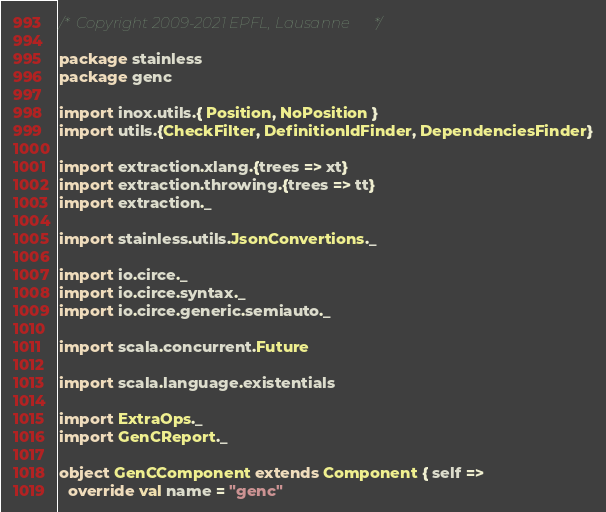Convert code to text. <code><loc_0><loc_0><loc_500><loc_500><_Scala_>/* Copyright 2009-2021 EPFL, Lausanne */

package stainless
package genc

import inox.utils.{ Position, NoPosition }
import utils.{CheckFilter, DefinitionIdFinder, DependenciesFinder}

import extraction.xlang.{trees => xt}
import extraction.throwing.{trees => tt}
import extraction._

import stainless.utils.JsonConvertions._

import io.circe._
import io.circe.syntax._
import io.circe.generic.semiauto._

import scala.concurrent.Future

import scala.language.existentials

import ExtraOps._
import GenCReport._

object GenCComponent extends Component { self =>
  override val name = "genc"</code> 